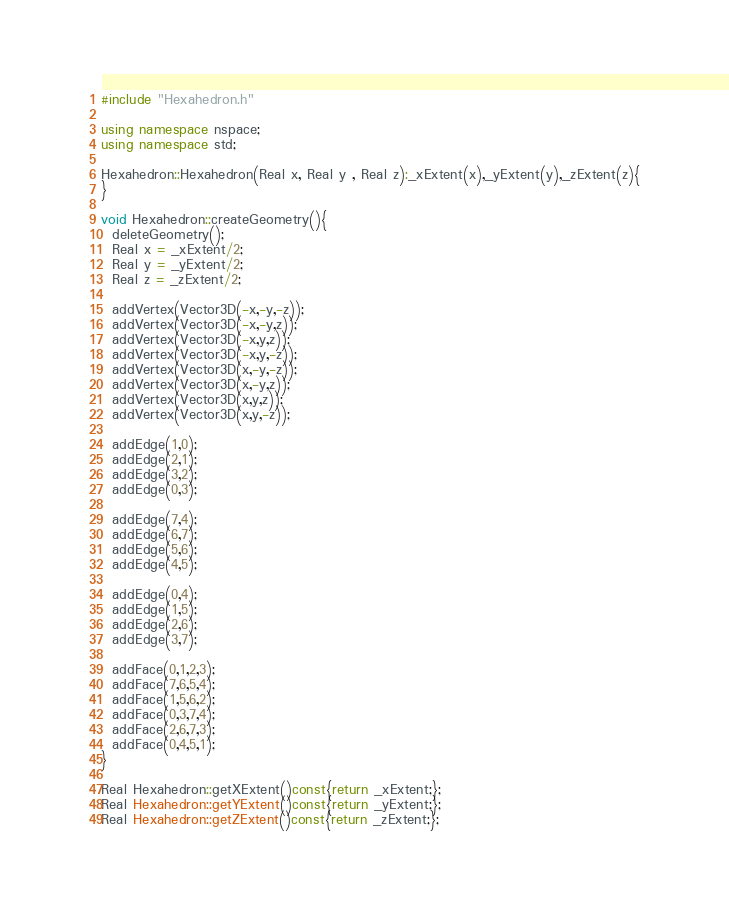<code> <loc_0><loc_0><loc_500><loc_500><_C++_>#include "Hexahedron.h"

using namespace nspace;
using namespace std;

Hexahedron::Hexahedron(Real x, Real y , Real z):_xExtent(x),_yExtent(y),_zExtent(z){
}

void Hexahedron::createGeometry(){
  deleteGeometry();
  Real x = _xExtent/2;
  Real y = _yExtent/2;
  Real z = _zExtent/2;

  addVertex(Vector3D(-x,-y,-z));
  addVertex(Vector3D(-x,-y,z));
  addVertex(Vector3D(-x,y,z));
  addVertex(Vector3D(-x,y,-z));
  addVertex(Vector3D(x,-y,-z));
  addVertex(Vector3D(x,-y,z));
  addVertex(Vector3D(x,y,z));
  addVertex(Vector3D(x,y,-z));

  addEdge(1,0);
  addEdge(2,1);
  addEdge(3,2);
  addEdge(0,3);

  addEdge(7,4);
  addEdge(6,7);
  addEdge(5,6);
  addEdge(4,5);

  addEdge(0,4);
  addEdge(1,5);
  addEdge(2,6);
  addEdge(3,7);

  addFace(0,1,2,3);
  addFace(7,6,5,4);
  addFace(1,5,6,2);
  addFace(0,3,7,4);
  addFace(2,6,7,3);
  addFace(0,4,5,1);
}

Real Hexahedron::getXExtent()const{return _xExtent;};
Real Hexahedron::getYExtent()const{return _yExtent;};
Real Hexahedron::getZExtent()const{return _zExtent;};</code> 